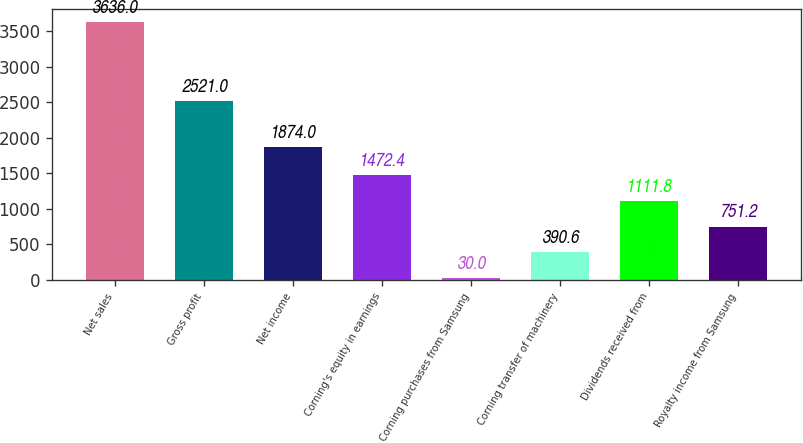<chart> <loc_0><loc_0><loc_500><loc_500><bar_chart><fcel>Net sales<fcel>Gross profit<fcel>Net income<fcel>Corning's equity in earnings<fcel>Corning purchases from Samsung<fcel>Corning transfer of machinery<fcel>Dividends received from<fcel>Royalty income from Samsung<nl><fcel>3636<fcel>2521<fcel>1874<fcel>1472.4<fcel>30<fcel>390.6<fcel>1111.8<fcel>751.2<nl></chart> 